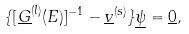<formula> <loc_0><loc_0><loc_500><loc_500>\{ [ \underline { G } ^ { ( l ) } ( E ) ] ^ { - 1 } - \underline { v } ^ { ( s ) } \} \underline { \psi } = \underline { 0 } ,</formula> 